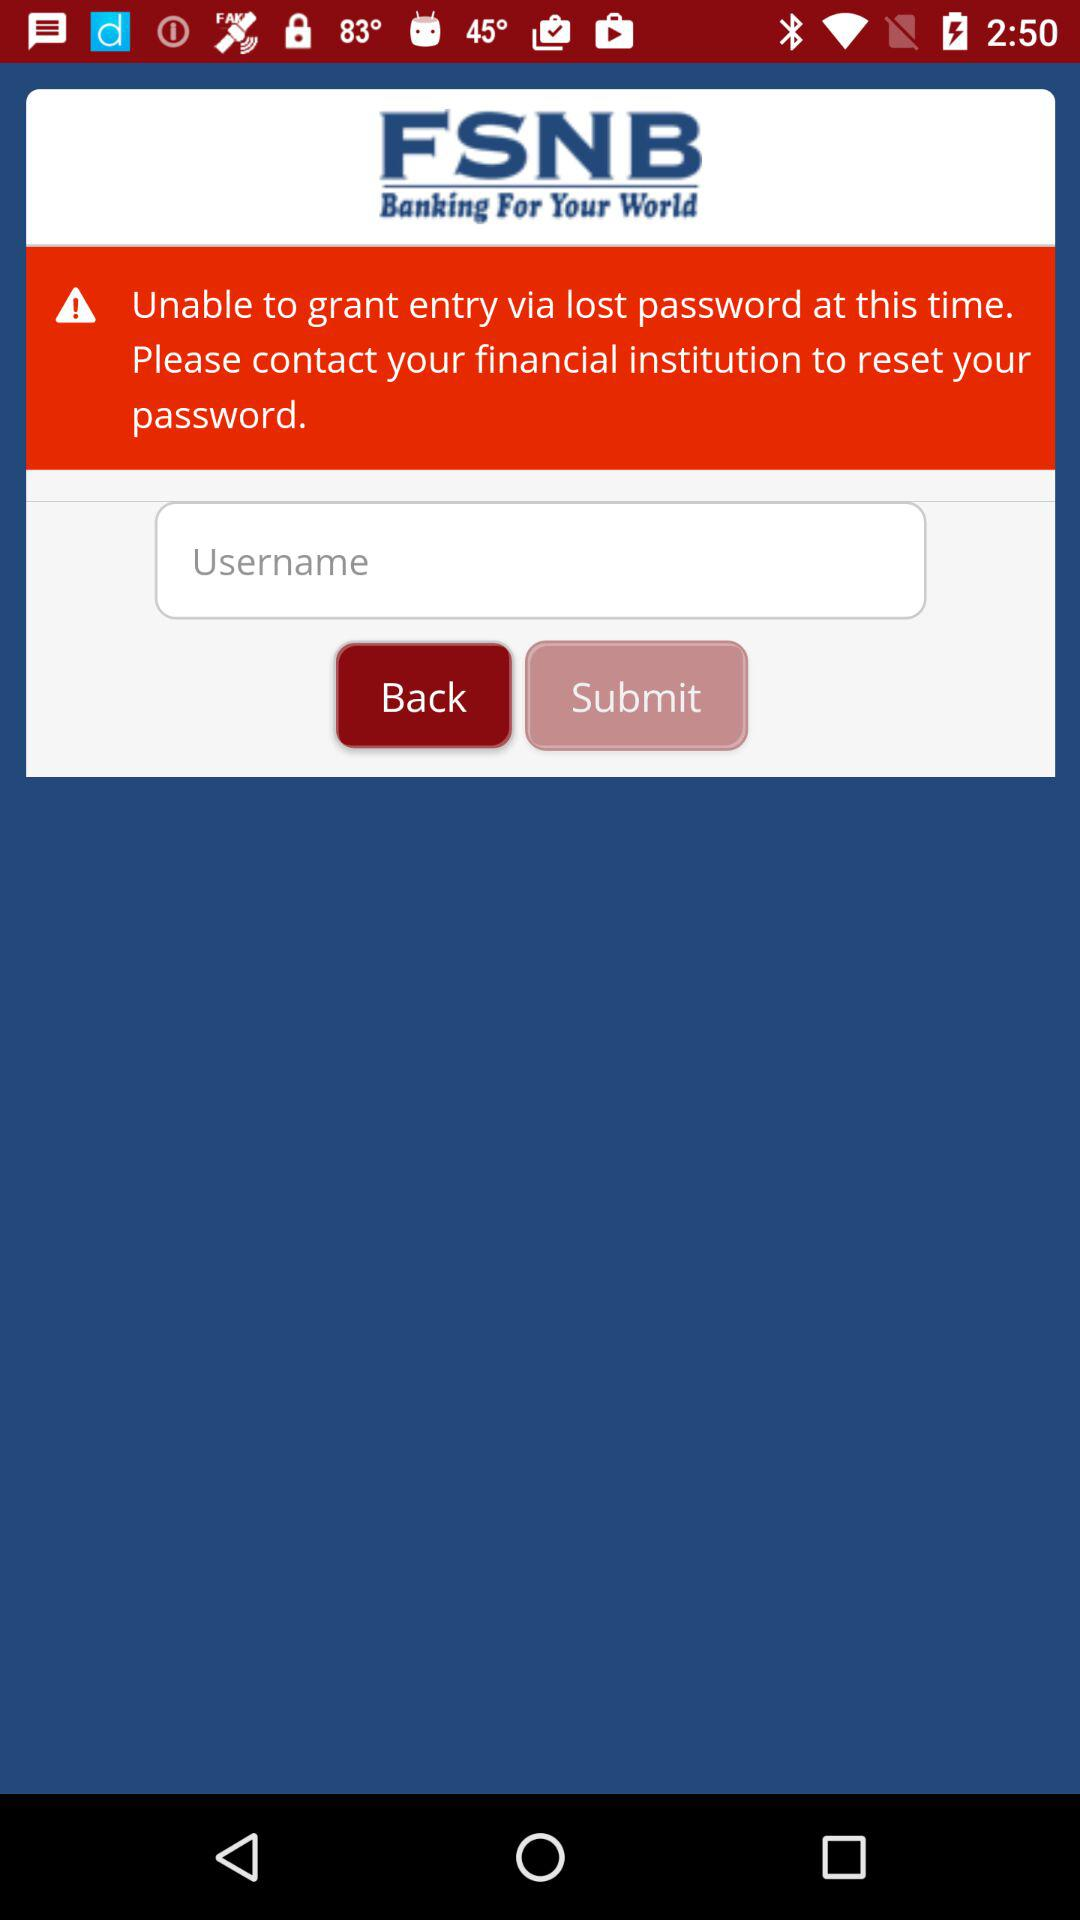What is the application name? The application name is "FSNB". 